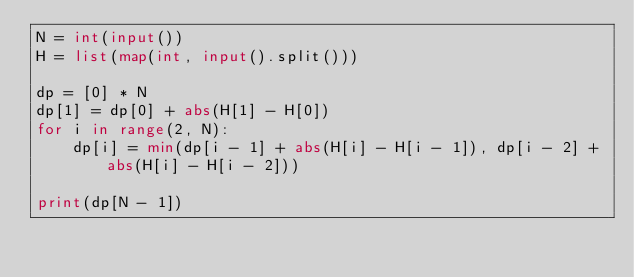Convert code to text. <code><loc_0><loc_0><loc_500><loc_500><_Python_>N = int(input())
H = list(map(int, input().split()))

dp = [0] * N
dp[1] = dp[0] + abs(H[1] - H[0])
for i in range(2, N):
    dp[i] = min(dp[i - 1] + abs(H[i] - H[i - 1]), dp[i - 2] + abs(H[i] - H[i - 2]))

print(dp[N - 1])</code> 